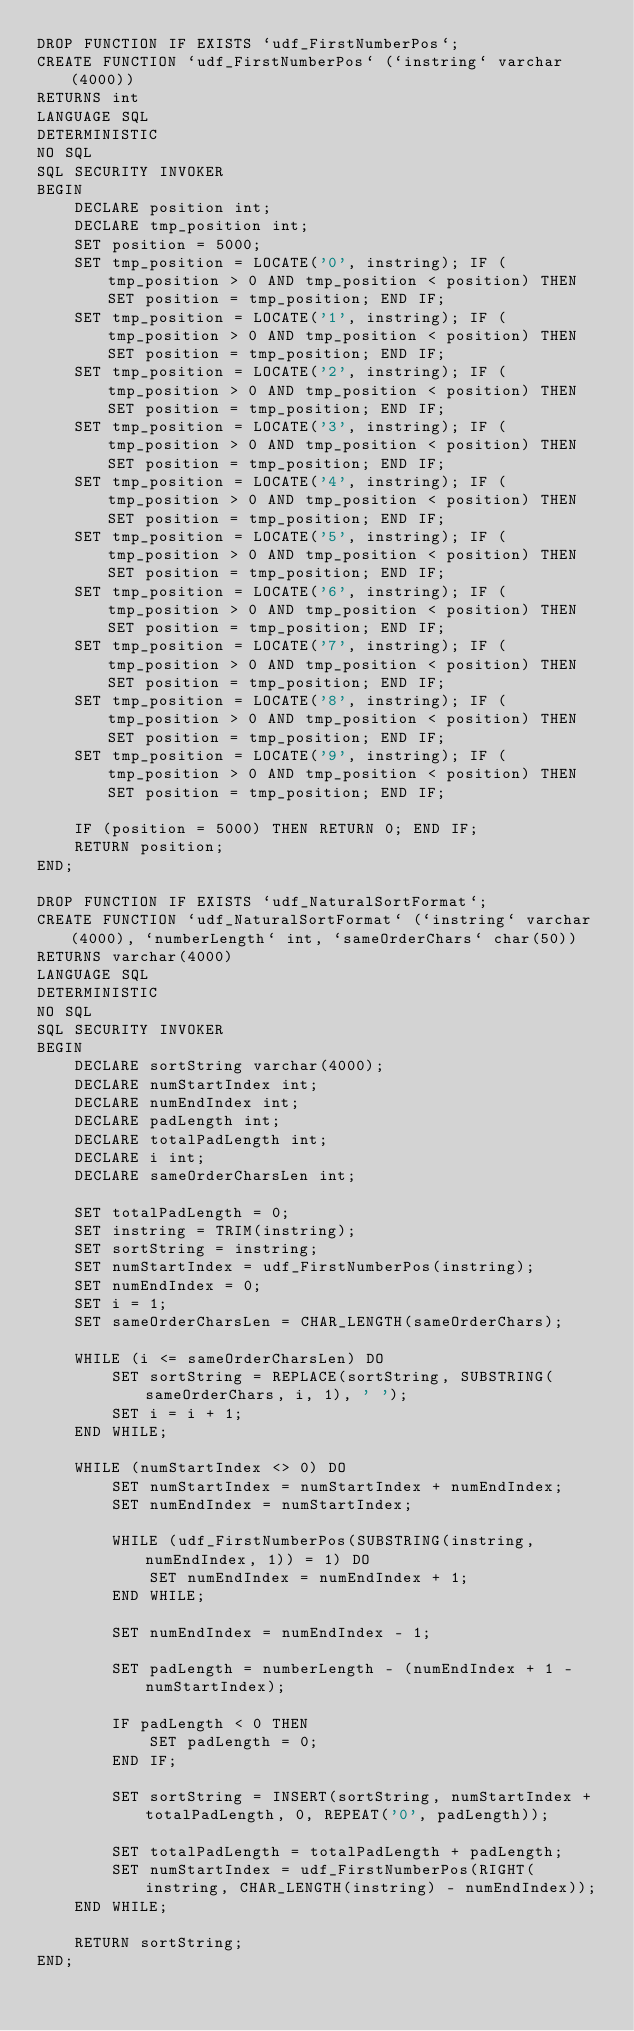<code> <loc_0><loc_0><loc_500><loc_500><_SQL_>DROP FUNCTION IF EXISTS `udf_FirstNumberPos`;
CREATE FUNCTION `udf_FirstNumberPos` (`instring` varchar(4000))
RETURNS int
LANGUAGE SQL
DETERMINISTIC
NO SQL
SQL SECURITY INVOKER
BEGIN
    DECLARE position int;
    DECLARE tmp_position int;
    SET position = 5000;
    SET tmp_position = LOCATE('0', instring); IF (tmp_position > 0 AND tmp_position < position) THEN SET position = tmp_position; END IF;
    SET tmp_position = LOCATE('1', instring); IF (tmp_position > 0 AND tmp_position < position) THEN SET position = tmp_position; END IF;
    SET tmp_position = LOCATE('2', instring); IF (tmp_position > 0 AND tmp_position < position) THEN SET position = tmp_position; END IF;
    SET tmp_position = LOCATE('3', instring); IF (tmp_position > 0 AND tmp_position < position) THEN SET position = tmp_position; END IF;
    SET tmp_position = LOCATE('4', instring); IF (tmp_position > 0 AND tmp_position < position) THEN SET position = tmp_position; END IF;
    SET tmp_position = LOCATE('5', instring); IF (tmp_position > 0 AND tmp_position < position) THEN SET position = tmp_position; END IF;
    SET tmp_position = LOCATE('6', instring); IF (tmp_position > 0 AND tmp_position < position) THEN SET position = tmp_position; END IF;
    SET tmp_position = LOCATE('7', instring); IF (tmp_position > 0 AND tmp_position < position) THEN SET position = tmp_position; END IF;
    SET tmp_position = LOCATE('8', instring); IF (tmp_position > 0 AND tmp_position < position) THEN SET position = tmp_position; END IF;
    SET tmp_position = LOCATE('9', instring); IF (tmp_position > 0 AND tmp_position < position) THEN SET position = tmp_position; END IF;

    IF (position = 5000) THEN RETURN 0; END IF;
    RETURN position;
END;

DROP FUNCTION IF EXISTS `udf_NaturalSortFormat`;
CREATE FUNCTION `udf_NaturalSortFormat` (`instring` varchar(4000), `numberLength` int, `sameOrderChars` char(50))
RETURNS varchar(4000)
LANGUAGE SQL
DETERMINISTIC
NO SQL
SQL SECURITY INVOKER
BEGIN
    DECLARE sortString varchar(4000);
    DECLARE numStartIndex int;
    DECLARE numEndIndex int;
    DECLARE padLength int;
    DECLARE totalPadLength int;
    DECLARE i int;
    DECLARE sameOrderCharsLen int;

    SET totalPadLength = 0;
    SET instring = TRIM(instring);
    SET sortString = instring;
    SET numStartIndex = udf_FirstNumberPos(instring);
    SET numEndIndex = 0;
    SET i = 1;
    SET sameOrderCharsLen = CHAR_LENGTH(sameOrderChars);

    WHILE (i <= sameOrderCharsLen) DO
        SET sortString = REPLACE(sortString, SUBSTRING(sameOrderChars, i, 1), ' ');
        SET i = i + 1;
    END WHILE;

    WHILE (numStartIndex <> 0) DO
        SET numStartIndex = numStartIndex + numEndIndex;
        SET numEndIndex = numStartIndex;

        WHILE (udf_FirstNumberPos(SUBSTRING(instring, numEndIndex, 1)) = 1) DO
            SET numEndIndex = numEndIndex + 1;
        END WHILE;

        SET numEndIndex = numEndIndex - 1;

        SET padLength = numberLength - (numEndIndex + 1 - numStartIndex);

        IF padLength < 0 THEN
            SET padLength = 0;
        END IF;

        SET sortString = INSERT(sortString, numStartIndex + totalPadLength, 0, REPEAT('0', padLength));

        SET totalPadLength = totalPadLength + padLength;
        SET numStartIndex = udf_FirstNumberPos(RIGHT(instring, CHAR_LENGTH(instring) - numEndIndex));
    END WHILE;

    RETURN sortString;
END;
</code> 